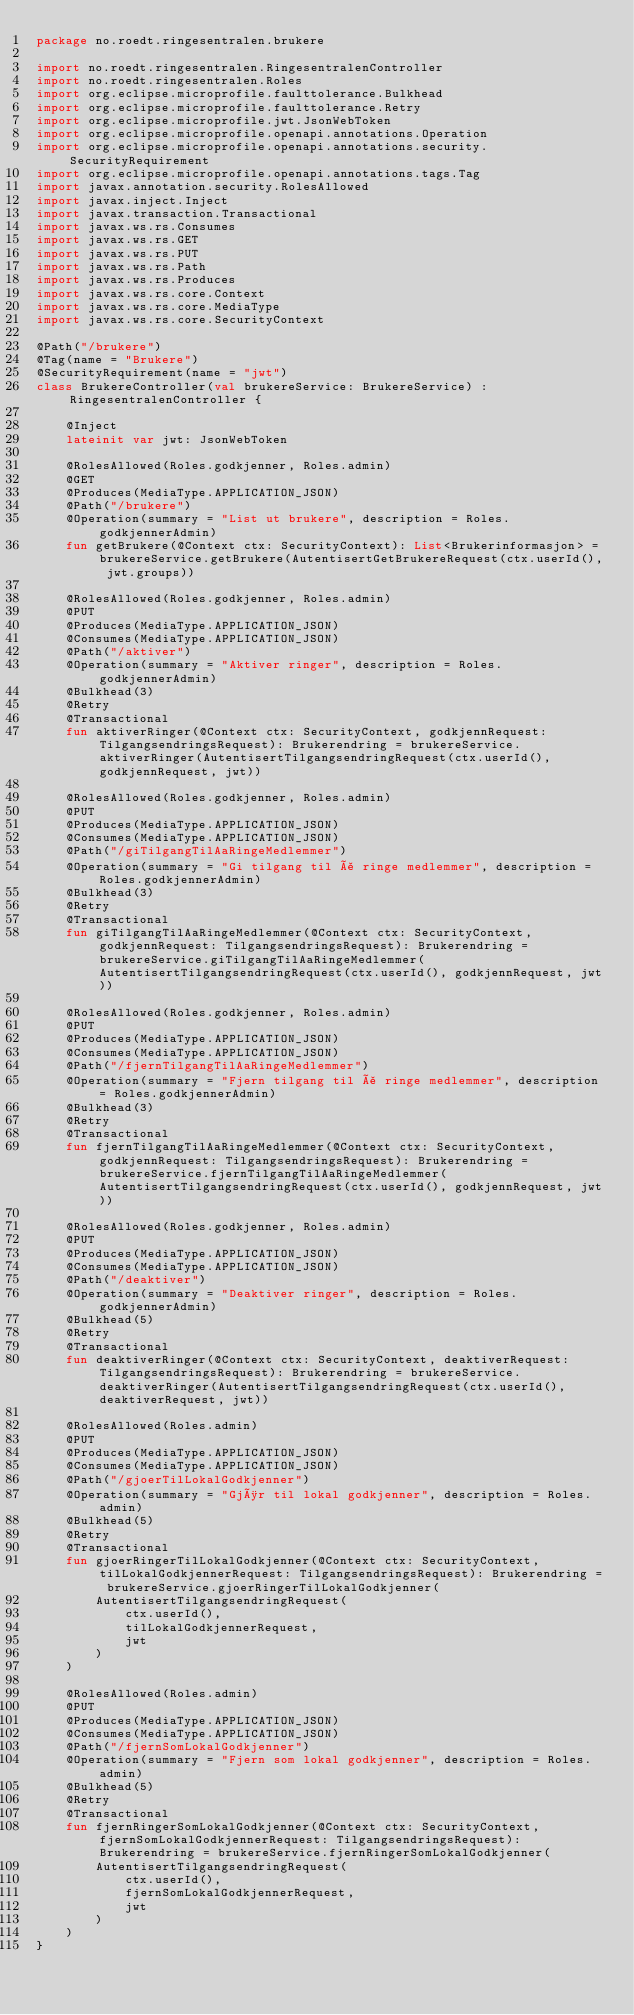Convert code to text. <code><loc_0><loc_0><loc_500><loc_500><_Kotlin_>package no.roedt.ringesentralen.brukere

import no.roedt.ringesentralen.RingesentralenController
import no.roedt.ringesentralen.Roles
import org.eclipse.microprofile.faulttolerance.Bulkhead
import org.eclipse.microprofile.faulttolerance.Retry
import org.eclipse.microprofile.jwt.JsonWebToken
import org.eclipse.microprofile.openapi.annotations.Operation
import org.eclipse.microprofile.openapi.annotations.security.SecurityRequirement
import org.eclipse.microprofile.openapi.annotations.tags.Tag
import javax.annotation.security.RolesAllowed
import javax.inject.Inject
import javax.transaction.Transactional
import javax.ws.rs.Consumes
import javax.ws.rs.GET
import javax.ws.rs.PUT
import javax.ws.rs.Path
import javax.ws.rs.Produces
import javax.ws.rs.core.Context
import javax.ws.rs.core.MediaType
import javax.ws.rs.core.SecurityContext

@Path("/brukere")
@Tag(name = "Brukere")
@SecurityRequirement(name = "jwt")
class BrukereController(val brukereService: BrukereService) : RingesentralenController {

    @Inject
    lateinit var jwt: JsonWebToken

    @RolesAllowed(Roles.godkjenner, Roles.admin)
    @GET
    @Produces(MediaType.APPLICATION_JSON)
    @Path("/brukere")
    @Operation(summary = "List ut brukere", description = Roles.godkjennerAdmin)
    fun getBrukere(@Context ctx: SecurityContext): List<Brukerinformasjon> = brukereService.getBrukere(AutentisertGetBrukereRequest(ctx.userId(), jwt.groups))

    @RolesAllowed(Roles.godkjenner, Roles.admin)
    @PUT
    @Produces(MediaType.APPLICATION_JSON)
    @Consumes(MediaType.APPLICATION_JSON)
    @Path("/aktiver")
    @Operation(summary = "Aktiver ringer", description = Roles.godkjennerAdmin)
    @Bulkhead(3)
    @Retry
    @Transactional
    fun aktiverRinger(@Context ctx: SecurityContext, godkjennRequest: TilgangsendringsRequest): Brukerendring = brukereService.aktiverRinger(AutentisertTilgangsendringRequest(ctx.userId(), godkjennRequest, jwt))

    @RolesAllowed(Roles.godkjenner, Roles.admin)
    @PUT
    @Produces(MediaType.APPLICATION_JSON)
    @Consumes(MediaType.APPLICATION_JSON)
    @Path("/giTilgangTilAaRingeMedlemmer")
    @Operation(summary = "Gi tilgang til å ringe medlemmer", description = Roles.godkjennerAdmin)
    @Bulkhead(3)
    @Retry
    @Transactional
    fun giTilgangTilAaRingeMedlemmer(@Context ctx: SecurityContext, godkjennRequest: TilgangsendringsRequest): Brukerendring = brukereService.giTilgangTilAaRingeMedlemmer(AutentisertTilgangsendringRequest(ctx.userId(), godkjennRequest, jwt))

    @RolesAllowed(Roles.godkjenner, Roles.admin)
    @PUT
    @Produces(MediaType.APPLICATION_JSON)
    @Consumes(MediaType.APPLICATION_JSON)
    @Path("/fjernTilgangTilAaRingeMedlemmer")
    @Operation(summary = "Fjern tilgang til å ringe medlemmer", description = Roles.godkjennerAdmin)
    @Bulkhead(3)
    @Retry
    @Transactional
    fun fjernTilgangTilAaRingeMedlemmer(@Context ctx: SecurityContext, godkjennRequest: TilgangsendringsRequest): Brukerendring = brukereService.fjernTilgangTilAaRingeMedlemmer(AutentisertTilgangsendringRequest(ctx.userId(), godkjennRequest, jwt))

    @RolesAllowed(Roles.godkjenner, Roles.admin)
    @PUT
    @Produces(MediaType.APPLICATION_JSON)
    @Consumes(MediaType.APPLICATION_JSON)
    @Path("/deaktiver")
    @Operation(summary = "Deaktiver ringer", description = Roles.godkjennerAdmin)
    @Bulkhead(5)
    @Retry
    @Transactional
    fun deaktiverRinger(@Context ctx: SecurityContext, deaktiverRequest: TilgangsendringsRequest): Brukerendring = brukereService.deaktiverRinger(AutentisertTilgangsendringRequest(ctx.userId(), deaktiverRequest, jwt))

    @RolesAllowed(Roles.admin)
    @PUT
    @Produces(MediaType.APPLICATION_JSON)
    @Consumes(MediaType.APPLICATION_JSON)
    @Path("/gjoerTilLokalGodkjenner")
    @Operation(summary = "Gjør til lokal godkjenner", description = Roles.admin)
    @Bulkhead(5)
    @Retry
    @Transactional
    fun gjoerRingerTilLokalGodkjenner(@Context ctx: SecurityContext, tilLokalGodkjennerRequest: TilgangsendringsRequest): Brukerendring = brukereService.gjoerRingerTilLokalGodkjenner(
        AutentisertTilgangsendringRequest(
            ctx.userId(),
            tilLokalGodkjennerRequest,
            jwt
        )
    )

    @RolesAllowed(Roles.admin)
    @PUT
    @Produces(MediaType.APPLICATION_JSON)
    @Consumes(MediaType.APPLICATION_JSON)
    @Path("/fjernSomLokalGodkjenner")
    @Operation(summary = "Fjern som lokal godkjenner", description = Roles.admin)
    @Bulkhead(5)
    @Retry
    @Transactional
    fun fjernRingerSomLokalGodkjenner(@Context ctx: SecurityContext, fjernSomLokalGodkjennerRequest: TilgangsendringsRequest): Brukerendring = brukereService.fjernRingerSomLokalGodkjenner(
        AutentisertTilgangsendringRequest(
            ctx.userId(),
            fjernSomLokalGodkjennerRequest,
            jwt
        )
    )
}
</code> 